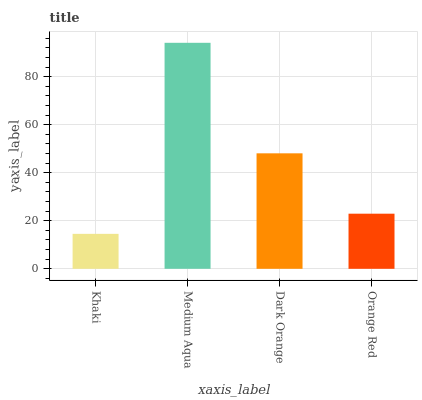Is Khaki the minimum?
Answer yes or no. Yes. Is Medium Aqua the maximum?
Answer yes or no. Yes. Is Dark Orange the minimum?
Answer yes or no. No. Is Dark Orange the maximum?
Answer yes or no. No. Is Medium Aqua greater than Dark Orange?
Answer yes or no. Yes. Is Dark Orange less than Medium Aqua?
Answer yes or no. Yes. Is Dark Orange greater than Medium Aqua?
Answer yes or no. No. Is Medium Aqua less than Dark Orange?
Answer yes or no. No. Is Dark Orange the high median?
Answer yes or no. Yes. Is Orange Red the low median?
Answer yes or no. Yes. Is Orange Red the high median?
Answer yes or no. No. Is Khaki the low median?
Answer yes or no. No. 